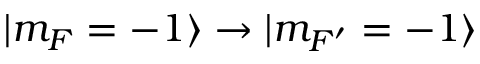Convert formula to latex. <formula><loc_0><loc_0><loc_500><loc_500>| m _ { F } = - 1 \rangle \rightarrow | m _ { F ^ { \prime } } = - 1 \rangle</formula> 